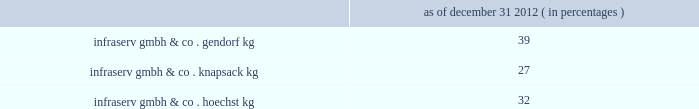Polyplastics co. , ltd .
Polyplastics is a leading supplier of engineered plastics in the asia-pacific region and is a venture between daicel chemical industries ltd. , japan ( 55% ( 55 % ) ) and ticona llc ( 45% ( 45 % ) ownership and a wholly-owned subsidiary of cna holdings llc ) .
Polyplastics is a producer and marketer of pom and lcp , with principal production facilities located in japan , taiwan , malaysia and china .
Fortron industries llc .
Fortron is a leading global producer of polyphenylene sulfide ( "pps" ) , sold under the fortron ae brand , which is used in a wide variety of automotive and other applications , especially those requiring heat and/or chemical resistance .
Fortron is a limited liability company whose members are ticona fortron inc .
( 50% ( 50 % ) ownership and a wholly-owned subsidiary of cna holdings llc ) and kureha corporation ( 50% ( 50 % ) ) .
Fortron's facility is located in wilmington , north carolina .
This venture combines the sales , marketing , distribution , compounding and manufacturing expertise of celanese with the pps polymer technology expertise of kureha .
China acetate strategic ventures .
We hold ownership interest in three separate acetate production ventures in china as follows : nantong cellulose fibers co .
Ltd .
( 31% ( 31 % ) ) , kunming cellulose fibers co .
Ltd .
( 30% ( 30 % ) ) and zhuhai cellulose fibers co .
Ltd .
( 30% ( 30 % ) ) .
The china national tobacco corporation , the chinese state-owned tobacco entity , controls the remaining ownership interest in each of these ventures .
Our chinese acetate ventures fund their operations using operating cash flow and pay a dividend in the second quarter of each fiscal year based on the ventures' performance for the preceding year .
In 2012 , 2011 and 2010 , we received cash dividends of $ 83 million , $ 78 million and $ 71 million , respectively .
During 2012 , our venture's nantong facility completed an expansion of its acetate flake and acetate tow capacity , each by 30000 tons .
We made contributions of $ 29 million over three years related to the capacity expansion in nantong .
Similar expansions since the ventures were formed have led to earnings growth and increased dividends for the company .
According to the euromonitor database services , china is estimated to have a 42% ( 42 % ) share of the world's 2011 cigarette consumption and is the fastest growing area for cigarette consumption at an estimated growth rate of 3.5% ( 3.5 % ) per year from 2011 through 2016 .
Combined , these ventures are a leader in chinese domestic acetate production and we believe we are well positioned to supply chinese cigarette producers .
Although our ownership interest in each of our china acetate ventures exceeds 20% ( 20 % ) , we account for these investments using the cost method of accounting because we determined that we cannot exercise significant influence over these entities due to local government investment in and influence over these entities , limitations on our involvement in the day-to-day operations and the present inability of the entities to provide timely financial information prepared in accordance with generally accepted accounting principles in the united states ( "us gaap" ) .
2022 other equity method investments infraservs .
We hold indirect ownership interests in several german infraserv groups that own and develop industrial parks and provide on-site general and administrative support to tenants .
Our ownership interest in the equity investments in infraserv ventures are as follows : as of december 31 , 2012 ( in percentages ) .
Raw materials and energy we purchase a variety of raw materials and energy from sources in many countries for use in our production processes .
We have a policy of maintaining , when available , multiple sources of supply for materials .
However , some of our individual plants may have single sources of supply for some of their raw materials , such as carbon monoxide , steam and acetaldehyde .
Although we have been able to obtain sufficient supplies of raw materials , there can be no assurance that unforeseen developments will not affect our raw material supply .
Even if we have multiple sources of supply for a raw material , there can be no assurance that these sources can make up for the loss of a major supplier .
It is also possible profitability will be adversely affected if we are required to qualify additional sources of supply to our specifications in the event of the loss of a sole supplier .
In addition , the price of raw materials varies , often substantially , from year to year. .
What is the percentage change in the cash dividends received by the company in 2012 compare to 2011? 
Computations: ((83 - 78) / 78)
Answer: 0.0641. 